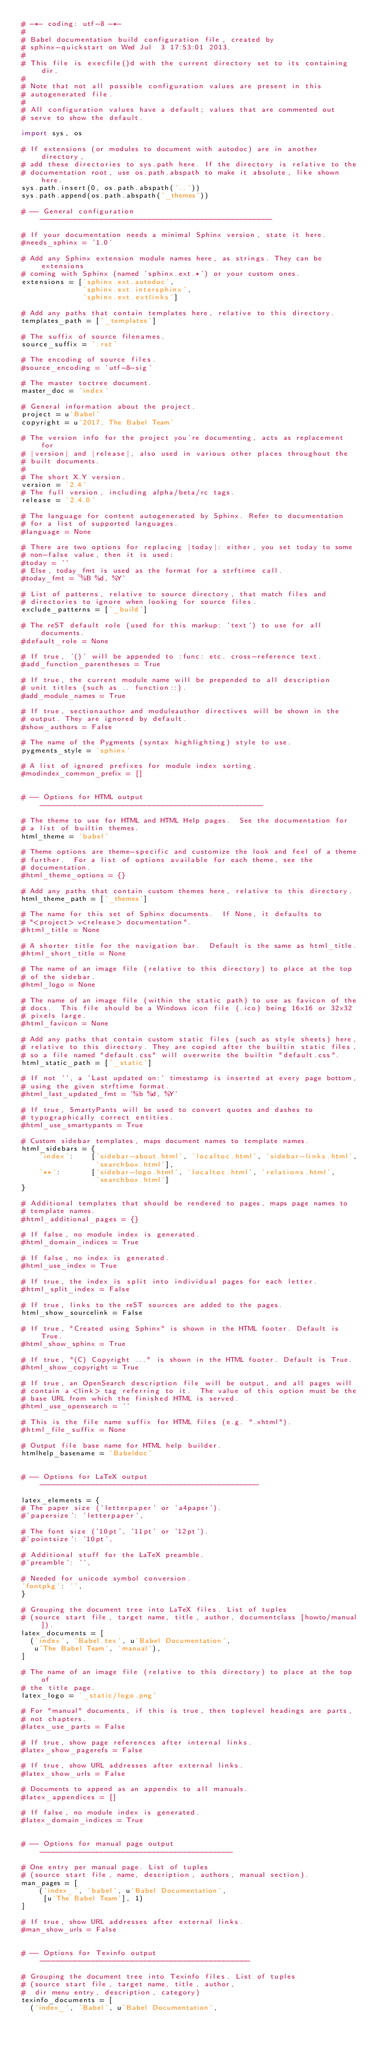<code> <loc_0><loc_0><loc_500><loc_500><_Python_># -*- coding: utf-8 -*-
#
# Babel documentation build configuration file, created by
# sphinx-quickstart on Wed Jul  3 17:53:01 2013.
#
# This file is execfile()d with the current directory set to its containing dir.
#
# Note that not all possible configuration values are present in this
# autogenerated file.
#
# All configuration values have a default; values that are commented out
# serve to show the default.

import sys, os

# If extensions (or modules to document with autodoc) are in another directory,
# add these directories to sys.path here. If the directory is relative to the
# documentation root, use os.path.abspath to make it absolute, like shown here.
sys.path.insert(0, os.path.abspath('..'))
sys.path.append(os.path.abspath('_themes'))

# -- General configuration -----------------------------------------------------

# If your documentation needs a minimal Sphinx version, state it here.
#needs_sphinx = '1.0'

# Add any Sphinx extension module names here, as strings. They can be extensions
# coming with Sphinx (named 'sphinx.ext.*') or your custom ones.
extensions = ['sphinx.ext.autodoc',
              'sphinx.ext.intersphinx',
              'sphinx.ext.extlinks']

# Add any paths that contain templates here, relative to this directory.
templates_path = ['_templates']

# The suffix of source filenames.
source_suffix = '.rst'

# The encoding of source files.
#source_encoding = 'utf-8-sig'

# The master toctree document.
master_doc = 'index'

# General information about the project.
project = u'Babel'
copyright = u'2017, The Babel Team'

# The version info for the project you're documenting, acts as replacement for
# |version| and |release|, also used in various other places throughout the
# built documents.
#
# The short X.Y version.
version = '2.4'
# The full version, including alpha/beta/rc tags.
release = '2.4.0'

# The language for content autogenerated by Sphinx. Refer to documentation
# for a list of supported languages.
#language = None

# There are two options for replacing |today|: either, you set today to some
# non-false value, then it is used:
#today = ''
# Else, today_fmt is used as the format for a strftime call.
#today_fmt = '%B %d, %Y'

# List of patterns, relative to source directory, that match files and
# directories to ignore when looking for source files.
exclude_patterns = ['_build']

# The reST default role (used for this markup: `text`) to use for all documents.
#default_role = None

# If true, '()' will be appended to :func: etc. cross-reference text.
#add_function_parentheses = True

# If true, the current module name will be prepended to all description
# unit titles (such as .. function::).
#add_module_names = True

# If true, sectionauthor and moduleauthor directives will be shown in the
# output. They are ignored by default.
#show_authors = False

# The name of the Pygments (syntax highlighting) style to use.
pygments_style = 'sphinx'

# A list of ignored prefixes for module index sorting.
#modindex_common_prefix = []


# -- Options for HTML output ---------------------------------------------------

# The theme to use for HTML and HTML Help pages.  See the documentation for
# a list of builtin themes.
html_theme = 'babel'

# Theme options are theme-specific and customize the look and feel of a theme
# further.  For a list of options available for each theme, see the
# documentation.
#html_theme_options = {}

# Add any paths that contain custom themes here, relative to this directory.
html_theme_path = ['_themes']

# The name for this set of Sphinx documents.  If None, it defaults to
# "<project> v<release> documentation".
#html_title = None

# A shorter title for the navigation bar.  Default is the same as html_title.
#html_short_title = None

# The name of an image file (relative to this directory) to place at the top
# of the sidebar.
#html_logo = None

# The name of an image file (within the static path) to use as favicon of the
# docs.  This file should be a Windows icon file (.ico) being 16x16 or 32x32
# pixels large.
#html_favicon = None

# Add any paths that contain custom static files (such as style sheets) here,
# relative to this directory. They are copied after the builtin static files,
# so a file named "default.css" will overwrite the builtin "default.css".
html_static_path = ['_static']

# If not '', a 'Last updated on:' timestamp is inserted at every page bottom,
# using the given strftime format.
#html_last_updated_fmt = '%b %d, %Y'

# If true, SmartyPants will be used to convert quotes and dashes to
# typographically correct entities.
#html_use_smartypants = True

# Custom sidebar templates, maps document names to template names.
html_sidebars = {
    'index':    ['sidebar-about.html', 'localtoc.html', 'sidebar-links.html',
                 'searchbox.html'],
    '**':       ['sidebar-logo.html', 'localtoc.html', 'relations.html',
                 'searchbox.html']
}

# Additional templates that should be rendered to pages, maps page names to
# template names.
#html_additional_pages = {}

# If false, no module index is generated.
#html_domain_indices = True

# If false, no index is generated.
#html_use_index = True

# If true, the index is split into individual pages for each letter.
#html_split_index = False

# If true, links to the reST sources are added to the pages.
html_show_sourcelink = False

# If true, "Created using Sphinx" is shown in the HTML footer. Default is True.
#html_show_sphinx = True

# If true, "(C) Copyright ..." is shown in the HTML footer. Default is True.
#html_show_copyright = True

# If true, an OpenSearch description file will be output, and all pages will
# contain a <link> tag referring to it.  The value of this option must be the
# base URL from which the finished HTML is served.
#html_use_opensearch = ''

# This is the file name suffix for HTML files (e.g. ".xhtml").
#html_file_suffix = None

# Output file base name for HTML help builder.
htmlhelp_basename = 'Babeldoc'


# -- Options for LaTeX output --------------------------------------------------

latex_elements = {
# The paper size ('letterpaper' or 'a4paper').
#'papersize': 'letterpaper',

# The font size ('10pt', '11pt' or '12pt').
#'pointsize': '10pt',

# Additional stuff for the LaTeX preamble.
#'preamble': '',

# Needed for unicode symbol conversion.
'fontpkg': '',
}

# Grouping the document tree into LaTeX files. List of tuples
# (source start file, target name, title, author, documentclass [howto/manual]).
latex_documents = [
  ('index', 'Babel.tex', u'Babel Documentation',
   u'The Babel Team', 'manual'),
]

# The name of an image file (relative to this directory) to place at the top of
# the title page.
latex_logo = '_static/logo.png'

# For "manual" documents, if this is true, then toplevel headings are parts,
# not chapters.
#latex_use_parts = False

# If true, show page references after internal links.
#latex_show_pagerefs = False

# If true, show URL addresses after external links.
#latex_show_urls = False

# Documents to append as an appendix to all manuals.
#latex_appendices = []

# If false, no module index is generated.
#latex_domain_indices = True


# -- Options for manual page output --------------------------------------------

# One entry per manual page. List of tuples
# (source start file, name, description, authors, manual section).
man_pages = [
    ('index_', 'babel', u'Babel Documentation',
     [u'The Babel Team'], 1)
]

# If true, show URL addresses after external links.
#man_show_urls = False


# -- Options for Texinfo output ------------------------------------------------

# Grouping the document tree into Texinfo files. List of tuples
# (source start file, target name, title, author,
#  dir menu entry, description, category)
texinfo_documents = [
  ('index_', 'Babel', u'Babel Documentation',</code> 